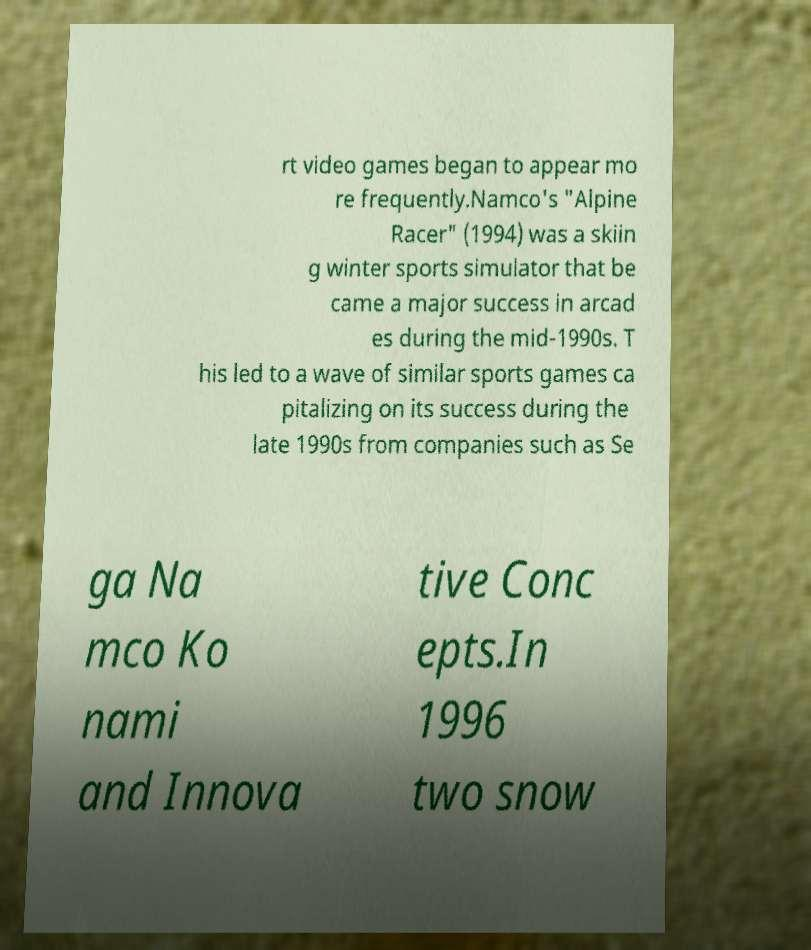Can you accurately transcribe the text from the provided image for me? rt video games began to appear mo re frequently.Namco's "Alpine Racer" (1994) was a skiin g winter sports simulator that be came a major success in arcad es during the mid-1990s. T his led to a wave of similar sports games ca pitalizing on its success during the late 1990s from companies such as Se ga Na mco Ko nami and Innova tive Conc epts.In 1996 two snow 